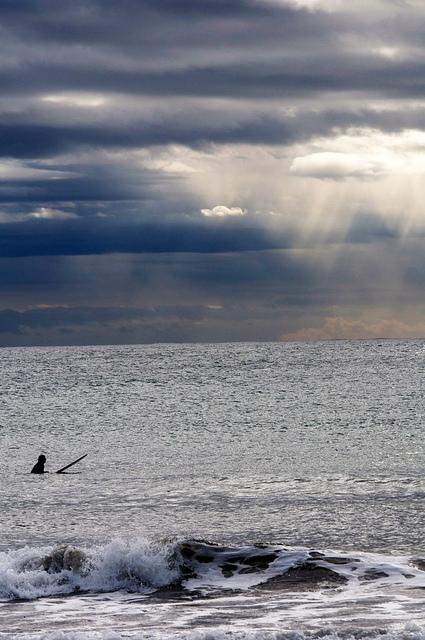Do you see any dolphins in the water?
Answer briefly. No. What is the man laying on?
Answer briefly. Surfboard. What time of day is it in this picture?
Keep it brief. Afternoon. What is the man holding?
Keep it brief. Surfboard. Is it sunny?
Give a very brief answer. No. 